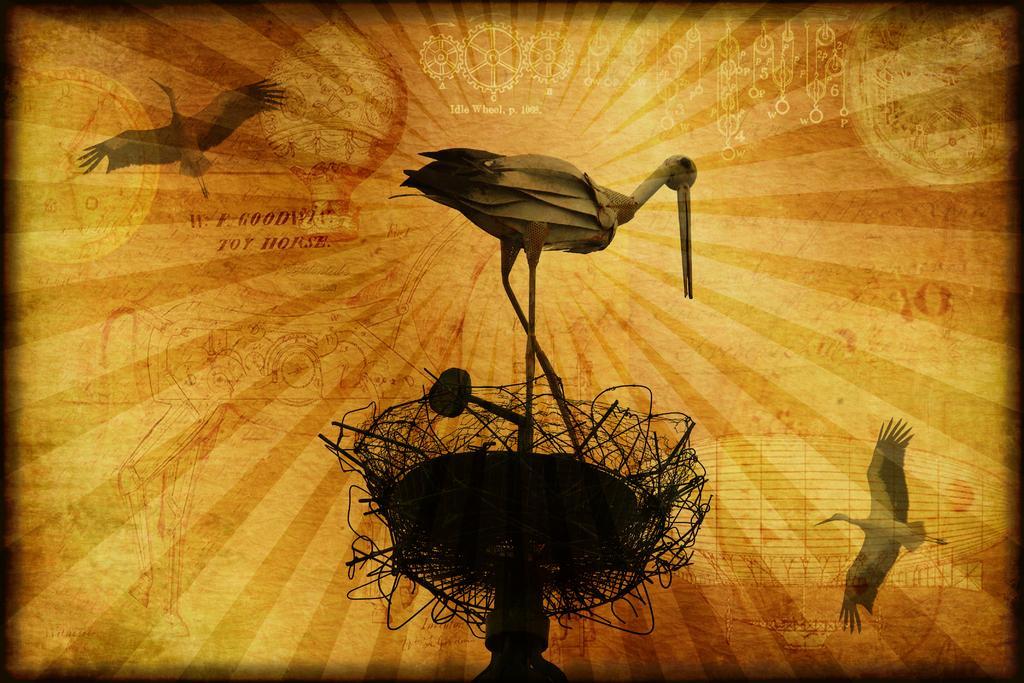Please provide a concise description of this image. In this image we can see a poster, on that there are three birds images, and there is a stand, also we can see some texts and other images on that. 